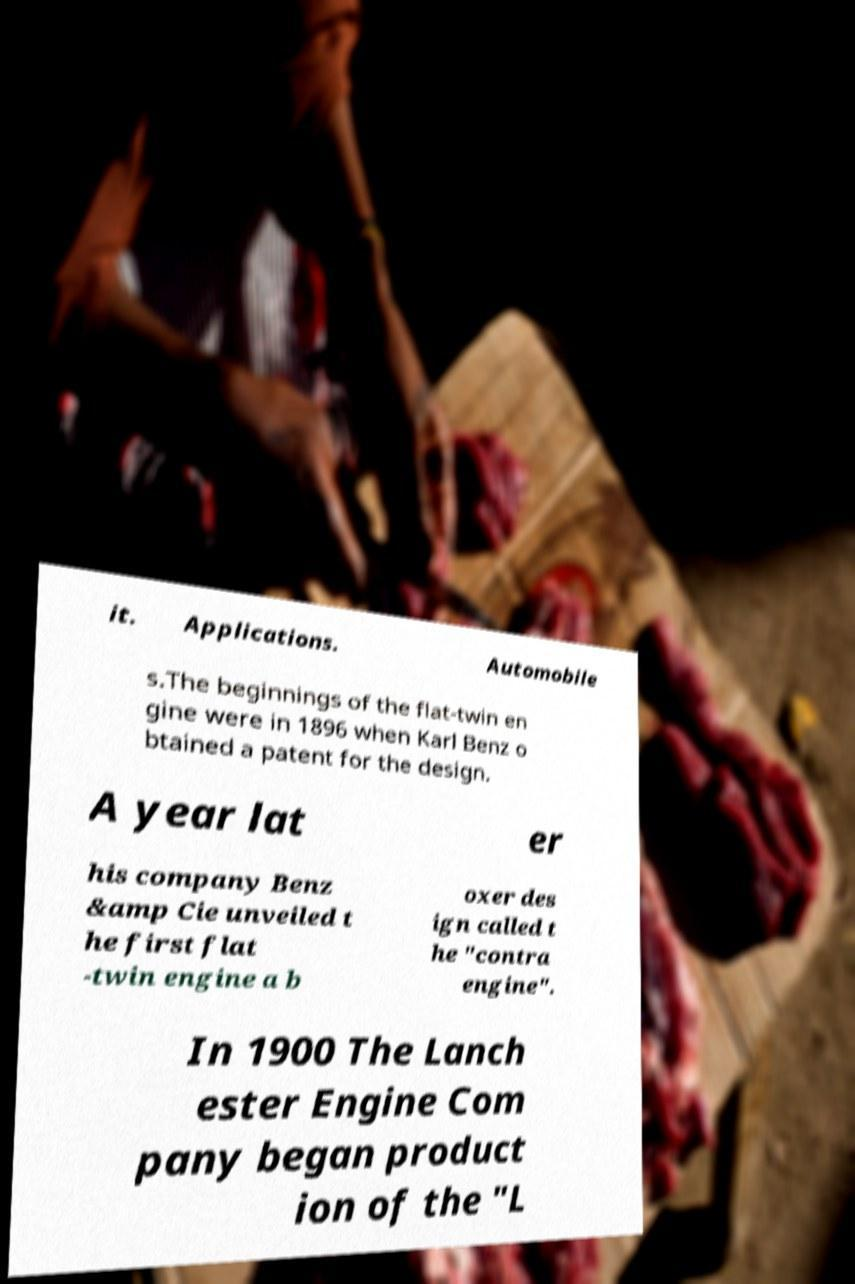Can you read and provide the text displayed in the image?This photo seems to have some interesting text. Can you extract and type it out for me? it. Applications. Automobile s.The beginnings of the flat-twin en gine were in 1896 when Karl Benz o btained a patent for the design. A year lat er his company Benz &amp Cie unveiled t he first flat -twin engine a b oxer des ign called t he "contra engine". In 1900 The Lanch ester Engine Com pany began product ion of the "L 